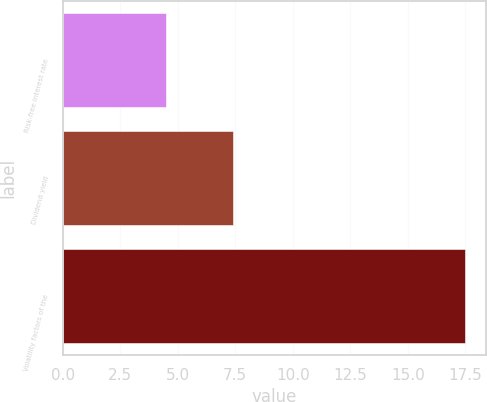<chart> <loc_0><loc_0><loc_500><loc_500><bar_chart><fcel>Risk-free interest rate<fcel>Dividend yield<fcel>Volatility factors of the<nl><fcel>4.5<fcel>7.4<fcel>17.5<nl></chart> 